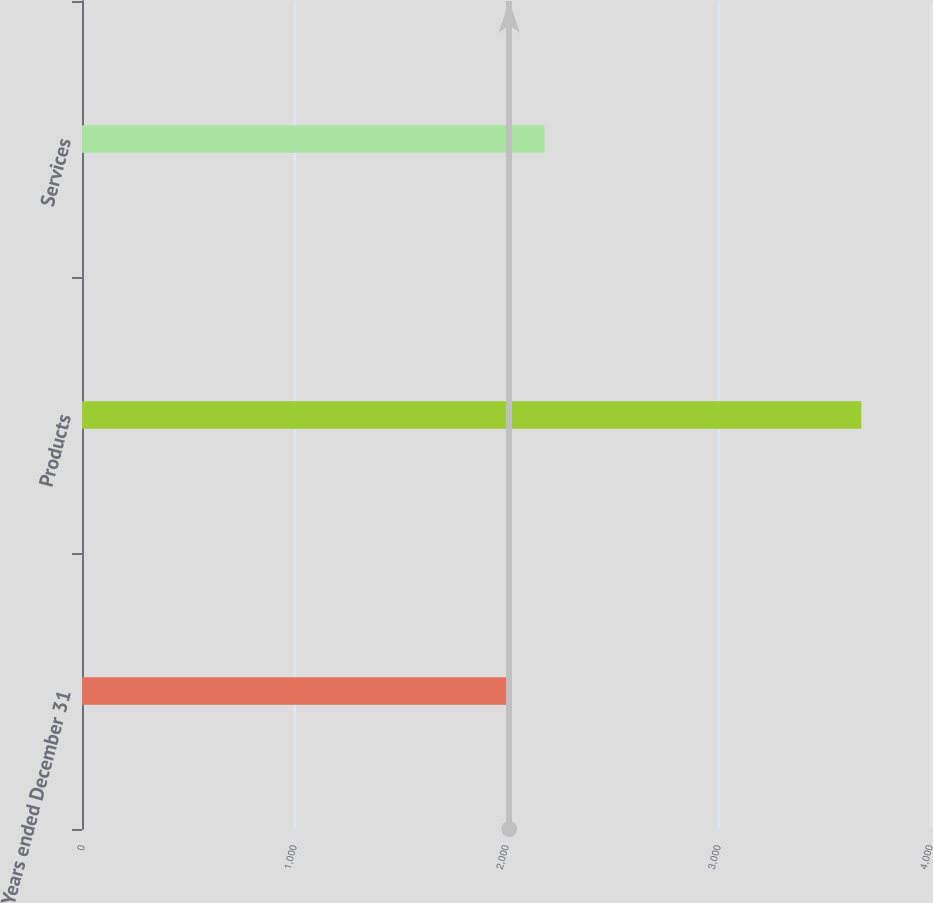Convert chart. <chart><loc_0><loc_0><loc_500><loc_500><bar_chart><fcel>Years ended December 31<fcel>Products<fcel>Services<nl><fcel>2015<fcel>3676<fcel>2181.1<nl></chart> 